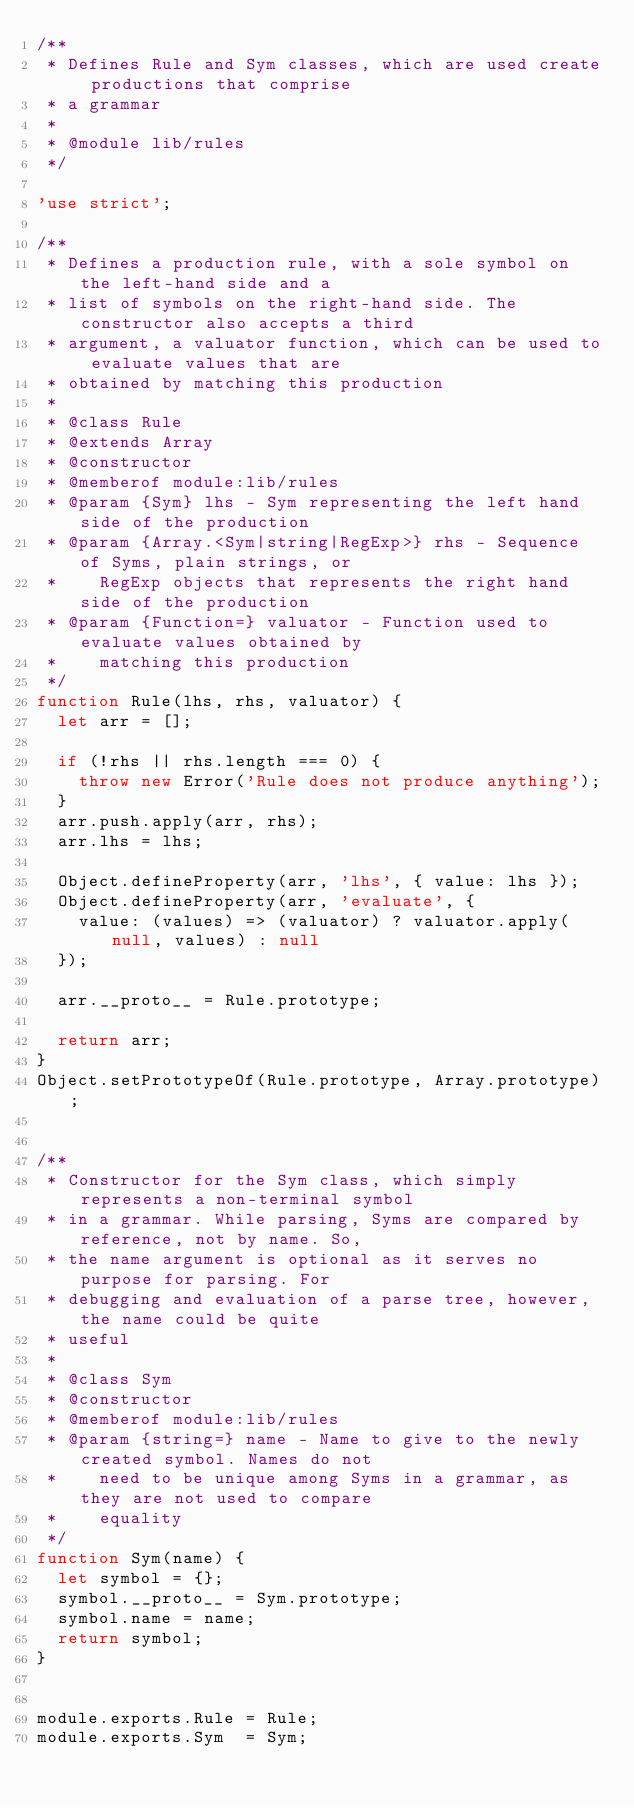<code> <loc_0><loc_0><loc_500><loc_500><_JavaScript_>/**
 * Defines Rule and Sym classes, which are used create productions that comprise
 * a grammar
 *
 * @module lib/rules
 */

'use strict';

/**
 * Defines a production rule, with a sole symbol on the left-hand side and a
 * list of symbols on the right-hand side. The constructor also accepts a third
 * argument, a valuator function, which can be used to evaluate values that are
 * obtained by matching this production
 *
 * @class Rule
 * @extends Array
 * @constructor
 * @memberof module:lib/rules
 * @param {Sym} lhs - Sym representing the left hand side of the production
 * @param {Array.<Sym|string|RegExp>} rhs - Sequence of Syms, plain strings, or
 *    RegExp objects that represents the right hand side of the production
 * @param {Function=} valuator - Function used to evaluate values obtained by
 *    matching this production
 */
function Rule(lhs, rhs, valuator) {
  let arr = [];

  if (!rhs || rhs.length === 0) {
    throw new Error('Rule does not produce anything');
  }
  arr.push.apply(arr, rhs);
  arr.lhs = lhs;

  Object.defineProperty(arr, 'lhs', { value: lhs });
  Object.defineProperty(arr, 'evaluate', {
    value: (values) => (valuator) ? valuator.apply(null, values) : null
  });

  arr.__proto__ = Rule.prototype;

  return arr;
}
Object.setPrototypeOf(Rule.prototype, Array.prototype);


/**
 * Constructor for the Sym class, which simply represents a non-terminal symbol
 * in a grammar. While parsing, Syms are compared by reference, not by name. So,
 * the name argument is optional as it serves no purpose for parsing. For
 * debugging and evaluation of a parse tree, however, the name could be quite
 * useful
 *
 * @class Sym
 * @constructor
 * @memberof module:lib/rules
 * @param {string=} name - Name to give to the newly created symbol. Names do not
 *    need to be unique among Syms in a grammar, as they are not used to compare
 *    equality
 */
function Sym(name) {
  let symbol = {};
  symbol.__proto__ = Sym.prototype;
  symbol.name = name;
  return symbol;
}


module.exports.Rule = Rule;
module.exports.Sym  = Sym;

</code> 